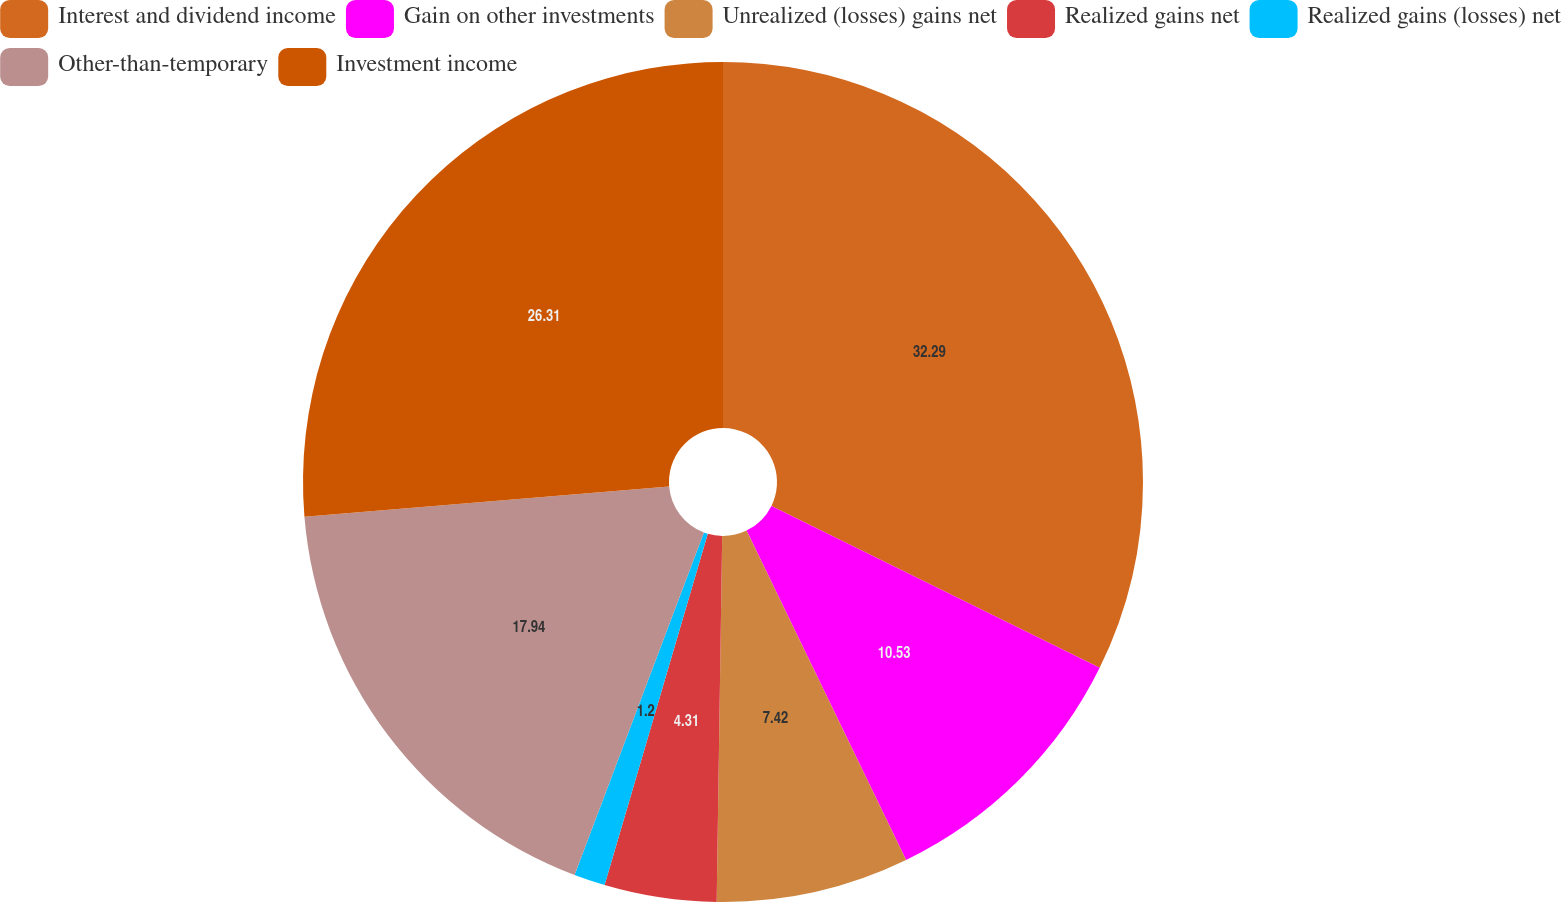<chart> <loc_0><loc_0><loc_500><loc_500><pie_chart><fcel>Interest and dividend income<fcel>Gain on other investments<fcel>Unrealized (losses) gains net<fcel>Realized gains net<fcel>Realized gains (losses) net<fcel>Other-than-temporary<fcel>Investment income<nl><fcel>32.3%<fcel>10.53%<fcel>7.42%<fcel>4.31%<fcel>1.2%<fcel>17.94%<fcel>26.32%<nl></chart> 